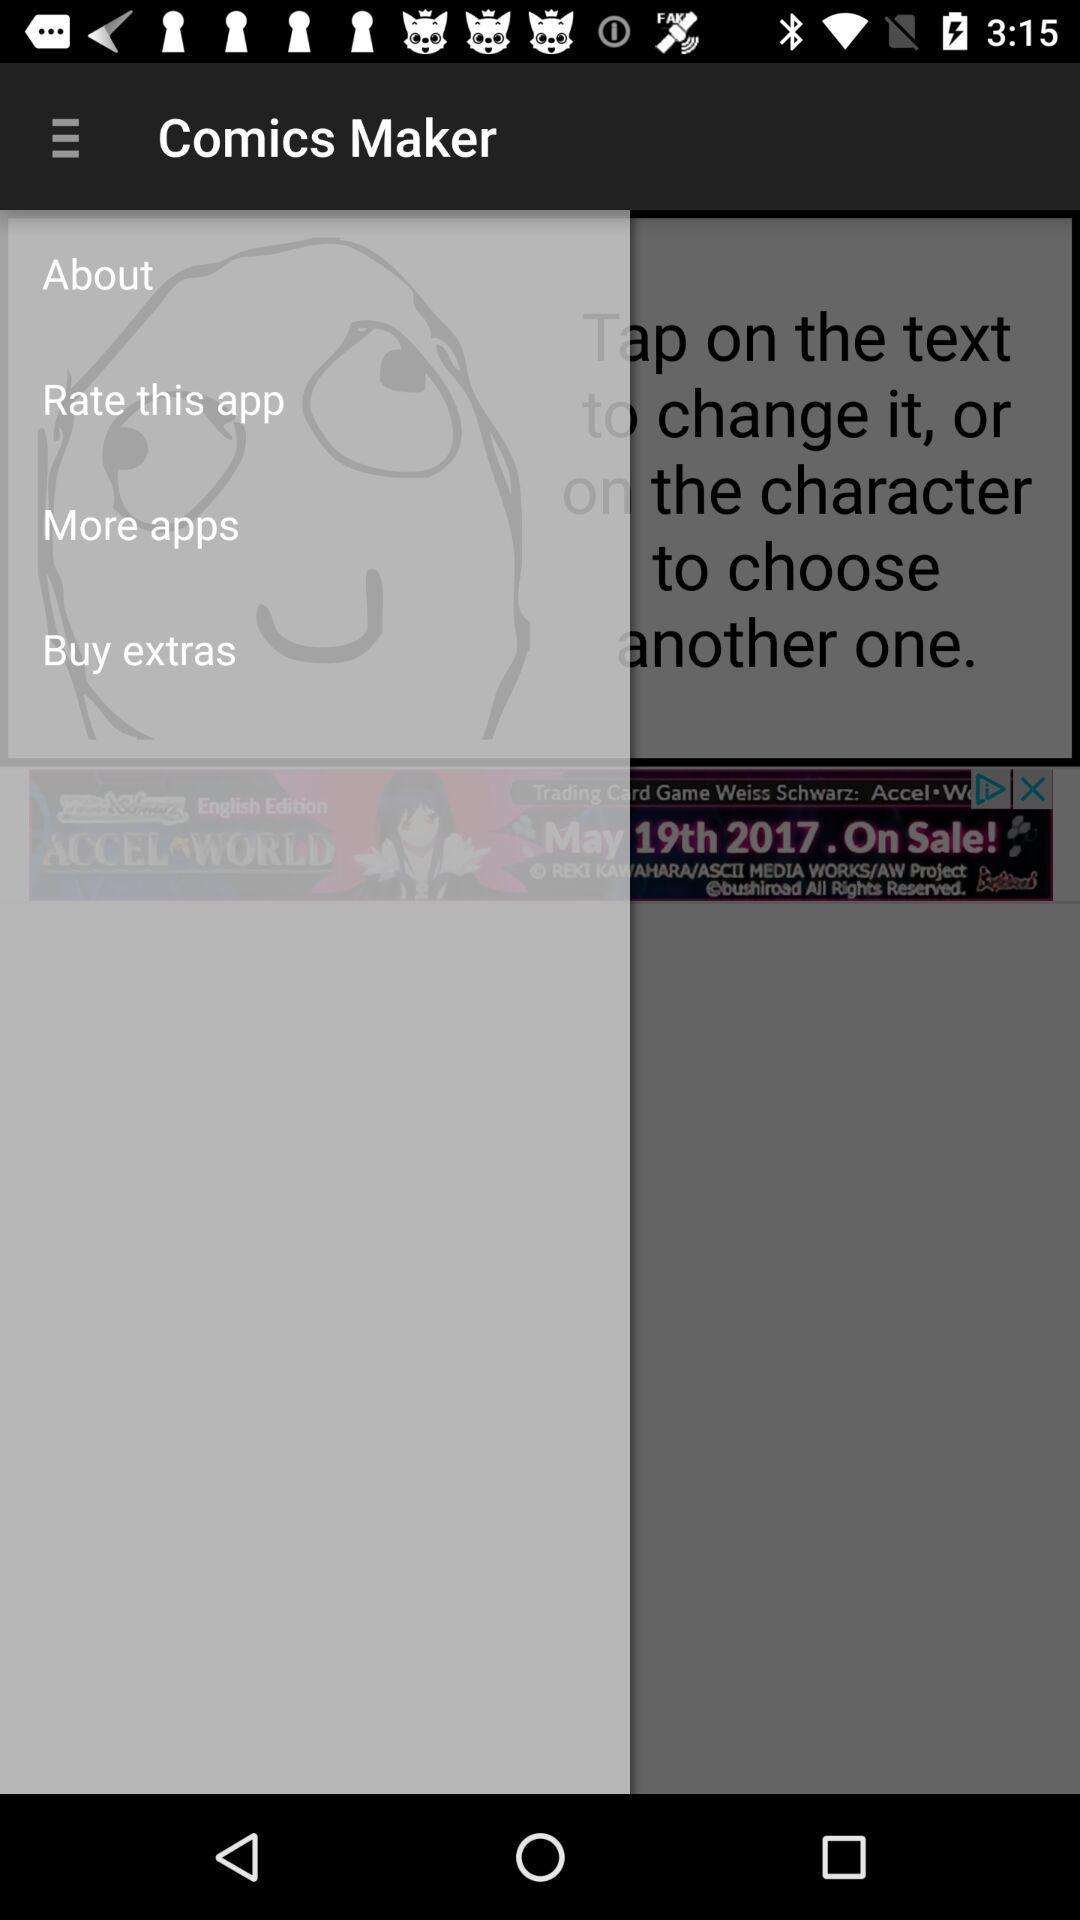What is the application name? The application name is "Comics Maker". 